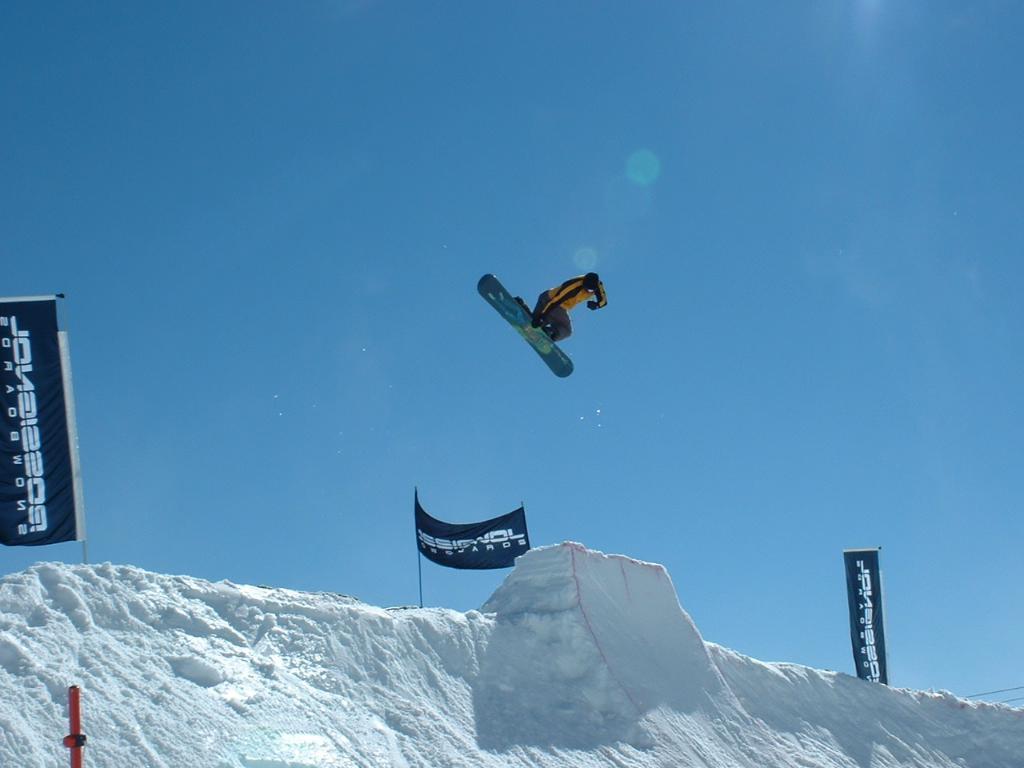How would you summarize this image in a sentence or two? In this image we can see a person doing snowboarding. At the bottom we can see the snow. On the snow we can see the banners with text. Behind the person we can see the sky. 